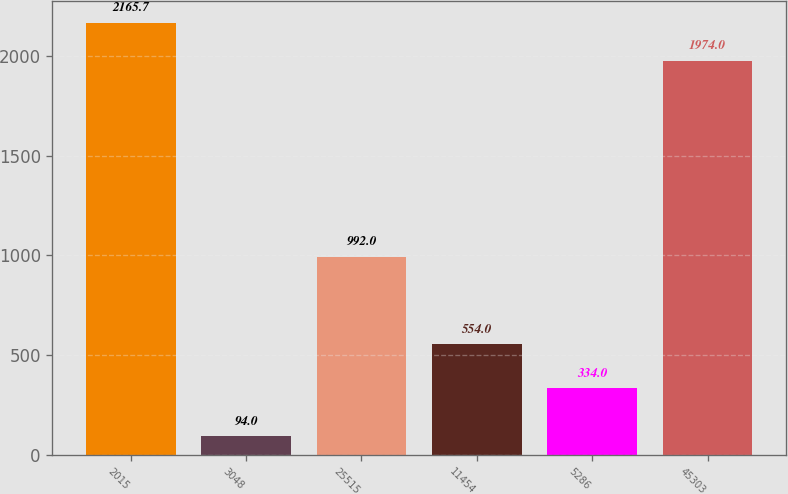Convert chart. <chart><loc_0><loc_0><loc_500><loc_500><bar_chart><fcel>2015<fcel>3048<fcel>25515<fcel>11454<fcel>5286<fcel>45303<nl><fcel>2165.7<fcel>94<fcel>992<fcel>554<fcel>334<fcel>1974<nl></chart> 